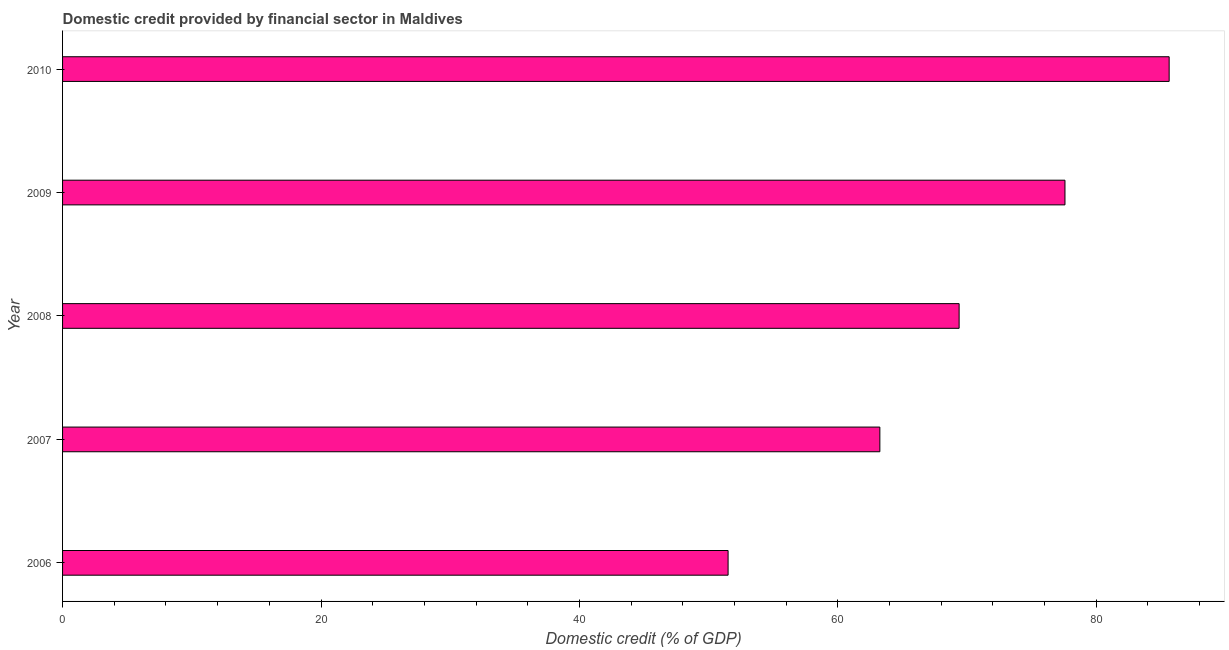What is the title of the graph?
Your answer should be very brief. Domestic credit provided by financial sector in Maldives. What is the label or title of the X-axis?
Give a very brief answer. Domestic credit (% of GDP). What is the domestic credit provided by financial sector in 2006?
Provide a succinct answer. 51.5. Across all years, what is the maximum domestic credit provided by financial sector?
Your answer should be very brief. 85.64. Across all years, what is the minimum domestic credit provided by financial sector?
Your answer should be compact. 51.5. What is the sum of the domestic credit provided by financial sector?
Your response must be concise. 347.35. What is the difference between the domestic credit provided by financial sector in 2006 and 2008?
Keep it short and to the point. -17.88. What is the average domestic credit provided by financial sector per year?
Your response must be concise. 69.47. What is the median domestic credit provided by financial sector?
Your answer should be very brief. 69.38. What is the ratio of the domestic credit provided by financial sector in 2006 to that in 2008?
Offer a terse response. 0.74. What is the difference between the highest and the second highest domestic credit provided by financial sector?
Offer a terse response. 8.06. Is the sum of the domestic credit provided by financial sector in 2007 and 2009 greater than the maximum domestic credit provided by financial sector across all years?
Provide a succinct answer. Yes. What is the difference between the highest and the lowest domestic credit provided by financial sector?
Make the answer very short. 34.13. How many years are there in the graph?
Offer a very short reply. 5. Are the values on the major ticks of X-axis written in scientific E-notation?
Keep it short and to the point. No. What is the Domestic credit (% of GDP) of 2006?
Provide a short and direct response. 51.5. What is the Domestic credit (% of GDP) of 2007?
Your response must be concise. 63.25. What is the Domestic credit (% of GDP) of 2008?
Offer a very short reply. 69.38. What is the Domestic credit (% of GDP) in 2009?
Provide a succinct answer. 77.58. What is the Domestic credit (% of GDP) of 2010?
Offer a terse response. 85.64. What is the difference between the Domestic credit (% of GDP) in 2006 and 2007?
Provide a short and direct response. -11.75. What is the difference between the Domestic credit (% of GDP) in 2006 and 2008?
Offer a very short reply. -17.88. What is the difference between the Domestic credit (% of GDP) in 2006 and 2009?
Your response must be concise. -26.07. What is the difference between the Domestic credit (% of GDP) in 2006 and 2010?
Your answer should be very brief. -34.13. What is the difference between the Domestic credit (% of GDP) in 2007 and 2008?
Provide a short and direct response. -6.13. What is the difference between the Domestic credit (% of GDP) in 2007 and 2009?
Your answer should be very brief. -14.33. What is the difference between the Domestic credit (% of GDP) in 2007 and 2010?
Keep it short and to the point. -22.39. What is the difference between the Domestic credit (% of GDP) in 2008 and 2009?
Keep it short and to the point. -8.19. What is the difference between the Domestic credit (% of GDP) in 2008 and 2010?
Make the answer very short. -16.26. What is the difference between the Domestic credit (% of GDP) in 2009 and 2010?
Provide a succinct answer. -8.06. What is the ratio of the Domestic credit (% of GDP) in 2006 to that in 2007?
Your response must be concise. 0.81. What is the ratio of the Domestic credit (% of GDP) in 2006 to that in 2008?
Make the answer very short. 0.74. What is the ratio of the Domestic credit (% of GDP) in 2006 to that in 2009?
Keep it short and to the point. 0.66. What is the ratio of the Domestic credit (% of GDP) in 2006 to that in 2010?
Keep it short and to the point. 0.6. What is the ratio of the Domestic credit (% of GDP) in 2007 to that in 2008?
Offer a very short reply. 0.91. What is the ratio of the Domestic credit (% of GDP) in 2007 to that in 2009?
Ensure brevity in your answer.  0.81. What is the ratio of the Domestic credit (% of GDP) in 2007 to that in 2010?
Your answer should be very brief. 0.74. What is the ratio of the Domestic credit (% of GDP) in 2008 to that in 2009?
Keep it short and to the point. 0.89. What is the ratio of the Domestic credit (% of GDP) in 2008 to that in 2010?
Provide a short and direct response. 0.81. What is the ratio of the Domestic credit (% of GDP) in 2009 to that in 2010?
Ensure brevity in your answer.  0.91. 